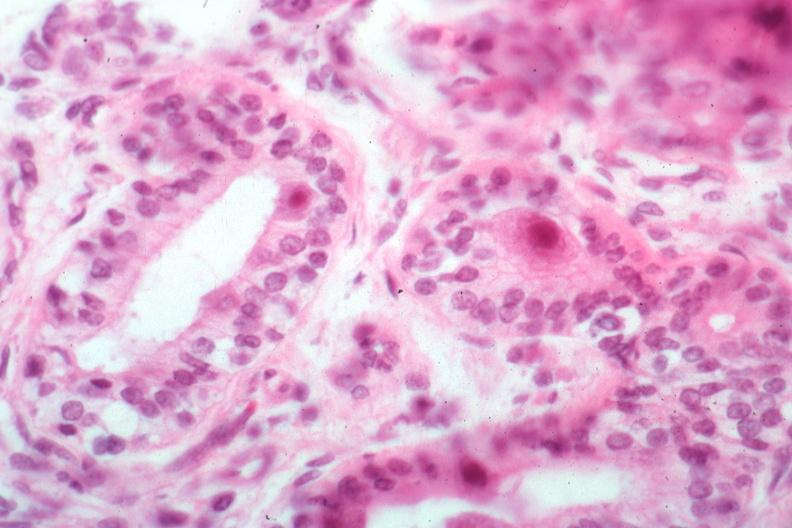what is present?
Answer the question using a single word or phrase. Cytomegalovirus 